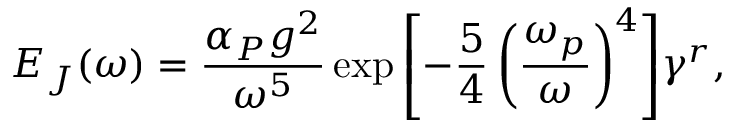Convert formula to latex. <formula><loc_0><loc_0><loc_500><loc_500>E _ { J } ( \omega ) = \frac { \alpha _ { P } g ^ { 2 } } { \omega ^ { 5 } } \exp { \left [ - \frac { 5 } { 4 } \left ( \frac { \omega _ { p } } { \omega } \right ) ^ { 4 } \right ] } \gamma ^ { r } ,</formula> 